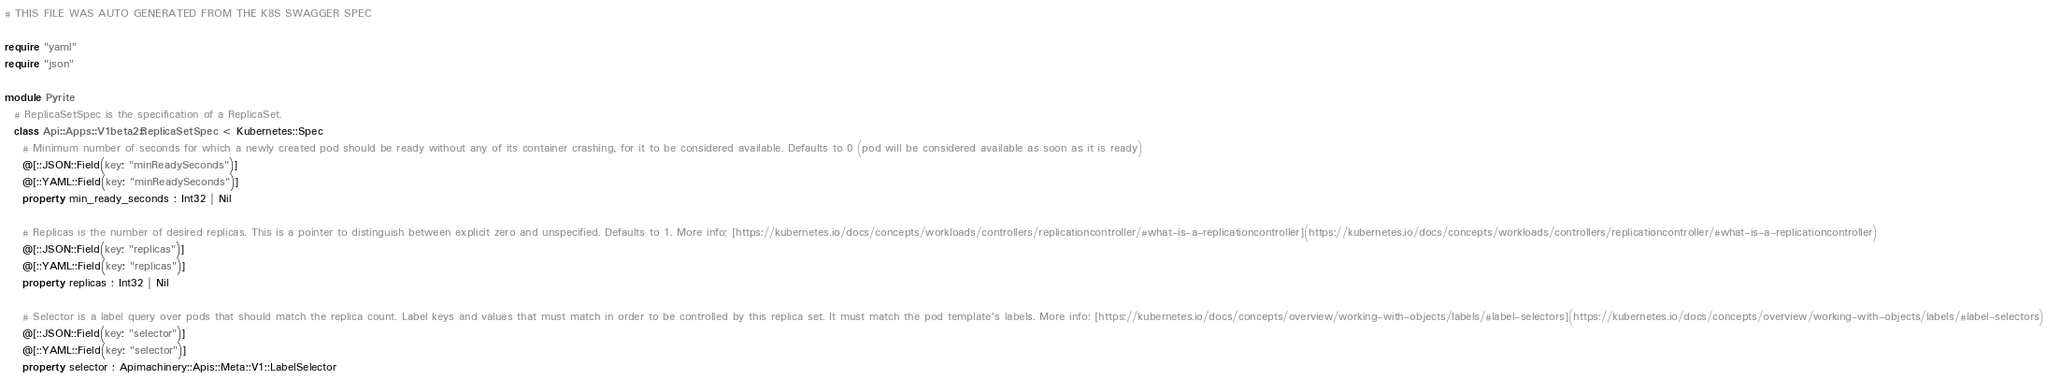Convert code to text. <code><loc_0><loc_0><loc_500><loc_500><_Crystal_># THIS FILE WAS AUTO GENERATED FROM THE K8S SWAGGER SPEC

require "yaml"
require "json"

module Pyrite
  # ReplicaSetSpec is the specification of a ReplicaSet.
  class Api::Apps::V1beta2::ReplicaSetSpec < Kubernetes::Spec
    # Minimum number of seconds for which a newly created pod should be ready without any of its container crashing, for it to be considered available. Defaults to 0 (pod will be considered available as soon as it is ready)
    @[::JSON::Field(key: "minReadySeconds")]
    @[::YAML::Field(key: "minReadySeconds")]
    property min_ready_seconds : Int32 | Nil

    # Replicas is the number of desired replicas. This is a pointer to distinguish between explicit zero and unspecified. Defaults to 1. More info: [https://kubernetes.io/docs/concepts/workloads/controllers/replicationcontroller/#what-is-a-replicationcontroller](https://kubernetes.io/docs/concepts/workloads/controllers/replicationcontroller/#what-is-a-replicationcontroller)
    @[::JSON::Field(key: "replicas")]
    @[::YAML::Field(key: "replicas")]
    property replicas : Int32 | Nil

    # Selector is a label query over pods that should match the replica count. Label keys and values that must match in order to be controlled by this replica set. It must match the pod template's labels. More info: [https://kubernetes.io/docs/concepts/overview/working-with-objects/labels/#label-selectors](https://kubernetes.io/docs/concepts/overview/working-with-objects/labels/#label-selectors)
    @[::JSON::Field(key: "selector")]
    @[::YAML::Field(key: "selector")]
    property selector : Apimachinery::Apis::Meta::V1::LabelSelector
</code> 